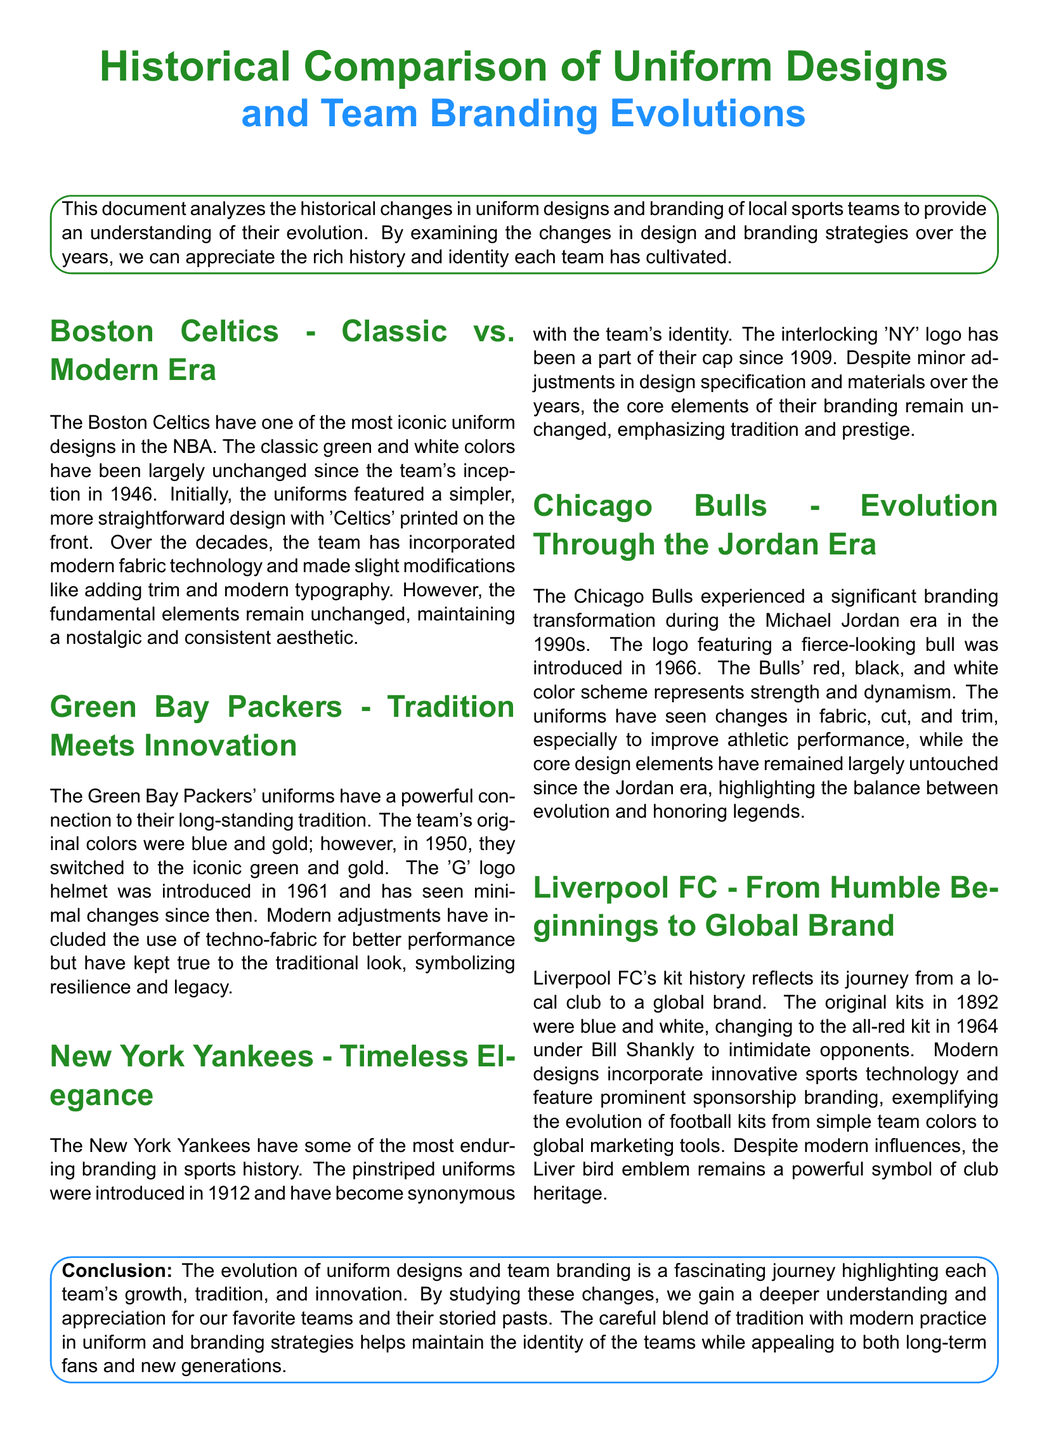What year did the Boston Celtics team start? The document states that the Boston Celtics were founded in 1946.
Answer: 1946 What colors did the Green Bay Packers originally use? The document mentions that the original colors for the Green Bay Packers were blue and gold.
Answer: Blue and gold When was the pinstriped uniform introduced for the New York Yankees? The pinstriped uniforms were introduced in 1912 according to the document.
Answer: 1912 What year did Liverpool FC change to the all-red kit? The change to the all-red kit occurred in 1964.
Answer: 1964 What type of material improvements have been incorporated in the Boston Celtics uniforms? The document states modern fabric technology has been used in their uniforms.
Answer: Modern fabric technology Which era marked a significant branding transformation for the Chicago Bulls? The document indicates the branding transformation occurred during the Michael Jordan era.
Answer: Michael Jordan era What logo was introduced for the Green Bay Packers in 1961? The document states that the 'G' logo helmet was introduced in 1961.
Answer: 'G' logo What does the Liver bird emblem symbolize? The document claims that the Liver bird emblem is a powerful symbol of club heritage.
Answer: Club heritage What is the main focus of the conclusion in the document? The conclusion emphasizes the evolution of uniform designs and team branding.
Answer: Evolution of uniform designs and team branding 